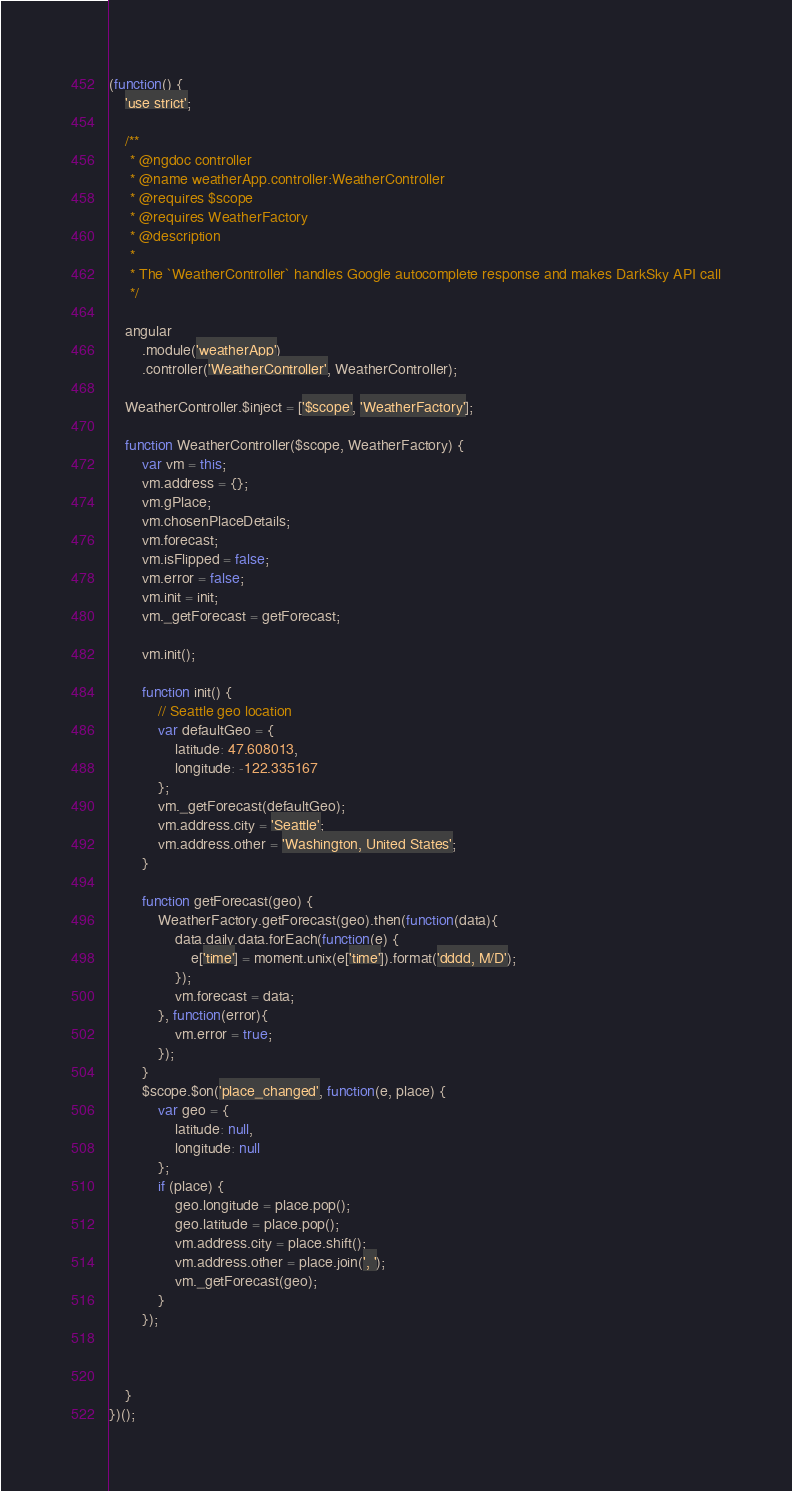Convert code to text. <code><loc_0><loc_0><loc_500><loc_500><_JavaScript_>(function() {
    'use strict';

    /**
     * @ngdoc controller
     * @name weatherApp.controller:WeatherController
     * @requires $scope
     * @requires WeatherFactory
     * @description
     *
     * The `WeatherController` handles Google autocomplete response and makes DarkSky API call
     */

    angular
        .module('weatherApp')
        .controller('WeatherController', WeatherController);

    WeatherController.$inject = ['$scope', 'WeatherFactory'];

    function WeatherController($scope, WeatherFactory) {
        var vm = this;
        vm.address = {};
        vm.gPlace;
        vm.chosenPlaceDetails;
        vm.forecast;
        vm.isFlipped = false;
        vm.error = false;
        vm.init = init;
        vm._getForecast = getForecast;

        vm.init();

        function init() {
            // Seattle geo location
            var defaultGeo = {
                latitude: 47.608013,
                longitude: -122.335167
            };
            vm._getForecast(defaultGeo);
            vm.address.city = 'Seattle';
            vm.address.other = 'Washington, United States';
        }

        function getForecast(geo) {
            WeatherFactory.getForecast(geo).then(function(data){
                data.daily.data.forEach(function(e) {
                    e['time'] = moment.unix(e['time']).format('dddd, M/D');
                });
                vm.forecast = data;
            }, function(error){
                vm.error = true;
            });
        }
        $scope.$on('place_changed', function(e, place) {
            var geo = {
                latitude: null,
                longitude: null
            };
            if (place) {
                geo.longitude = place.pop();
                geo.latitude = place.pop();
                vm.address.city = place.shift();
                vm.address.other = place.join(', ');
                vm._getForecast(geo);
            }
        });



    }
})();
</code> 